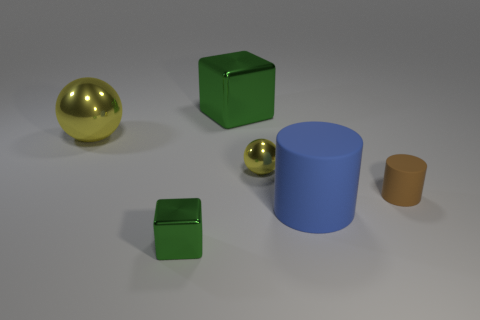What is the color of the metal cube that is the same size as the brown cylinder?
Give a very brief answer. Green. Are there any small yellow spheres made of the same material as the big blue cylinder?
Make the answer very short. No. Is the material of the cylinder right of the big blue rubber cylinder the same as the block that is behind the big blue matte object?
Your answer should be compact. No. How many big cyan cylinders are there?
Give a very brief answer. 0. There is a green shiny thing that is behind the blue object; what is its shape?
Offer a terse response. Cube. How many other things are the same size as the brown rubber thing?
Your answer should be compact. 2. There is a yellow metal object on the left side of the large block; is its shape the same as the yellow thing in front of the large metallic ball?
Keep it short and to the point. Yes. What number of green things are in front of the brown rubber cylinder?
Provide a short and direct response. 1. There is a small shiny sphere that is left of the small brown rubber cylinder; what color is it?
Your answer should be compact. Yellow. What is the color of the large thing that is the same shape as the tiny brown object?
Your response must be concise. Blue. 